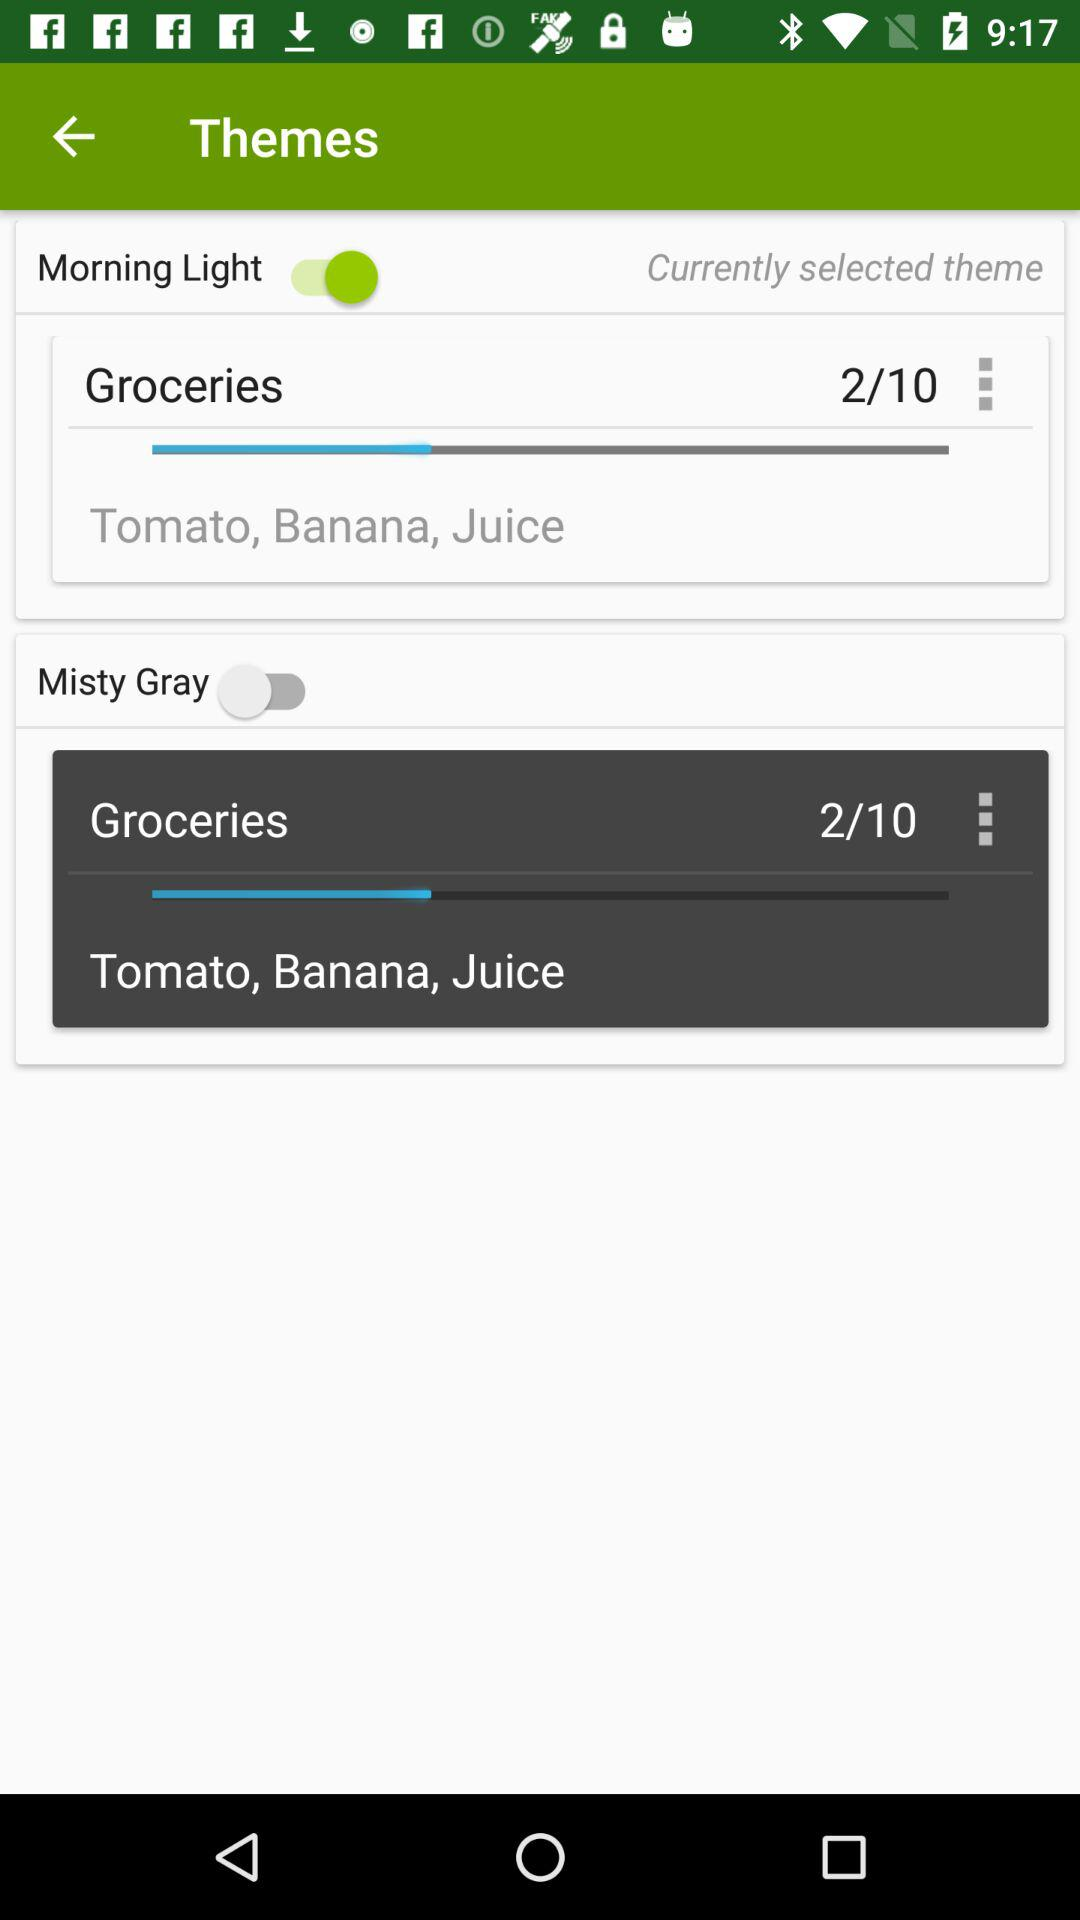How many groceries in total are there? There are 10 groceries in total. 